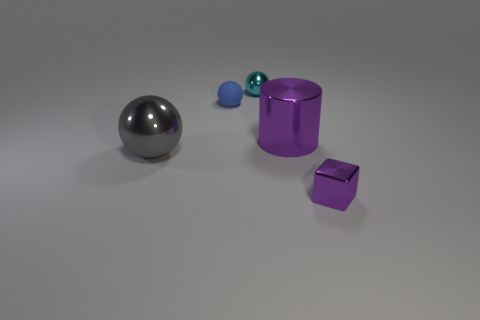Subtract all gray balls. Subtract all gray cylinders. How many balls are left? 2 Add 4 small red metal spheres. How many objects exist? 9 Subtract all spheres. How many objects are left? 2 Add 4 large purple metal things. How many large purple metal things exist? 5 Subtract 1 purple blocks. How many objects are left? 4 Subtract all tiny things. Subtract all large green balls. How many objects are left? 2 Add 3 tiny blue spheres. How many tiny blue spheres are left? 4 